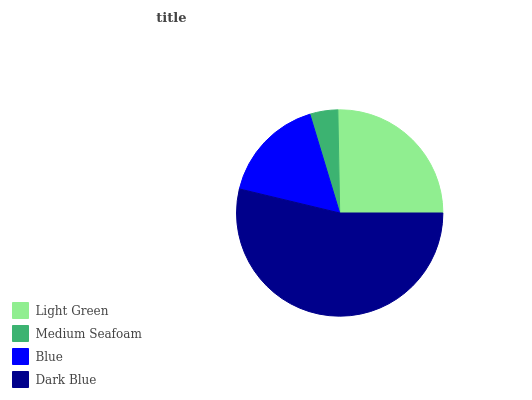Is Medium Seafoam the minimum?
Answer yes or no. Yes. Is Dark Blue the maximum?
Answer yes or no. Yes. Is Blue the minimum?
Answer yes or no. No. Is Blue the maximum?
Answer yes or no. No. Is Blue greater than Medium Seafoam?
Answer yes or no. Yes. Is Medium Seafoam less than Blue?
Answer yes or no. Yes. Is Medium Seafoam greater than Blue?
Answer yes or no. No. Is Blue less than Medium Seafoam?
Answer yes or no. No. Is Light Green the high median?
Answer yes or no. Yes. Is Blue the low median?
Answer yes or no. Yes. Is Medium Seafoam the high median?
Answer yes or no. No. Is Medium Seafoam the low median?
Answer yes or no. No. 